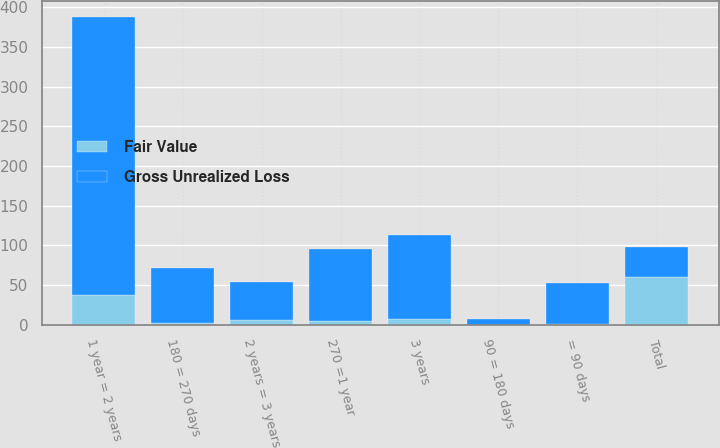Convert chart. <chart><loc_0><loc_0><loc_500><loc_500><stacked_bar_chart><ecel><fcel>= 90 days<fcel>90 = 180 days<fcel>180 = 270 days<fcel>270 =1 year<fcel>1 year = 2 years<fcel>2 years = 3 years<fcel>3 years<fcel>Total<nl><fcel>Gross Unrealized Loss<fcel>51<fcel>7.2<fcel>69.2<fcel>90.1<fcel>351.1<fcel>47.6<fcel>104.7<fcel>37.1<nl><fcel>Fair Value<fcel>1.6<fcel>0.2<fcel>2.5<fcel>5.3<fcel>37.1<fcel>6<fcel>7.9<fcel>60.6<nl></chart> 